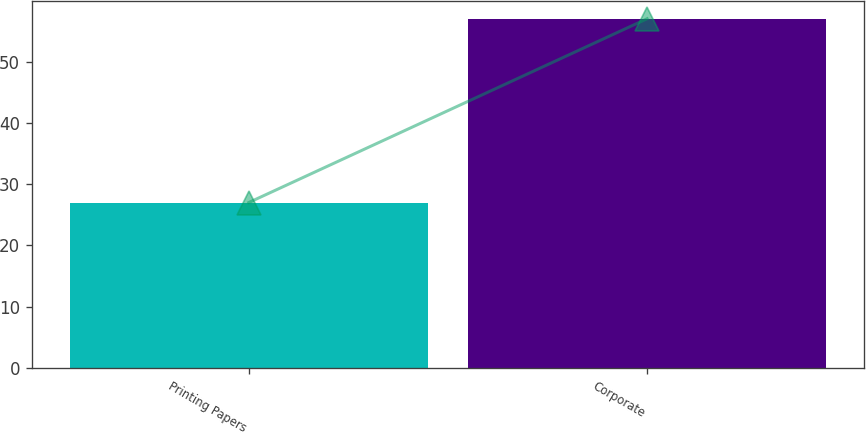Convert chart to OTSL. <chart><loc_0><loc_0><loc_500><loc_500><bar_chart><fcel>Printing Papers<fcel>Corporate<nl><fcel>27<fcel>57<nl></chart> 